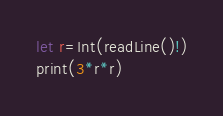Convert code to text. <code><loc_0><loc_0><loc_500><loc_500><_Swift_>let r=Int(readLine()!)
print(3*r*r)
</code> 